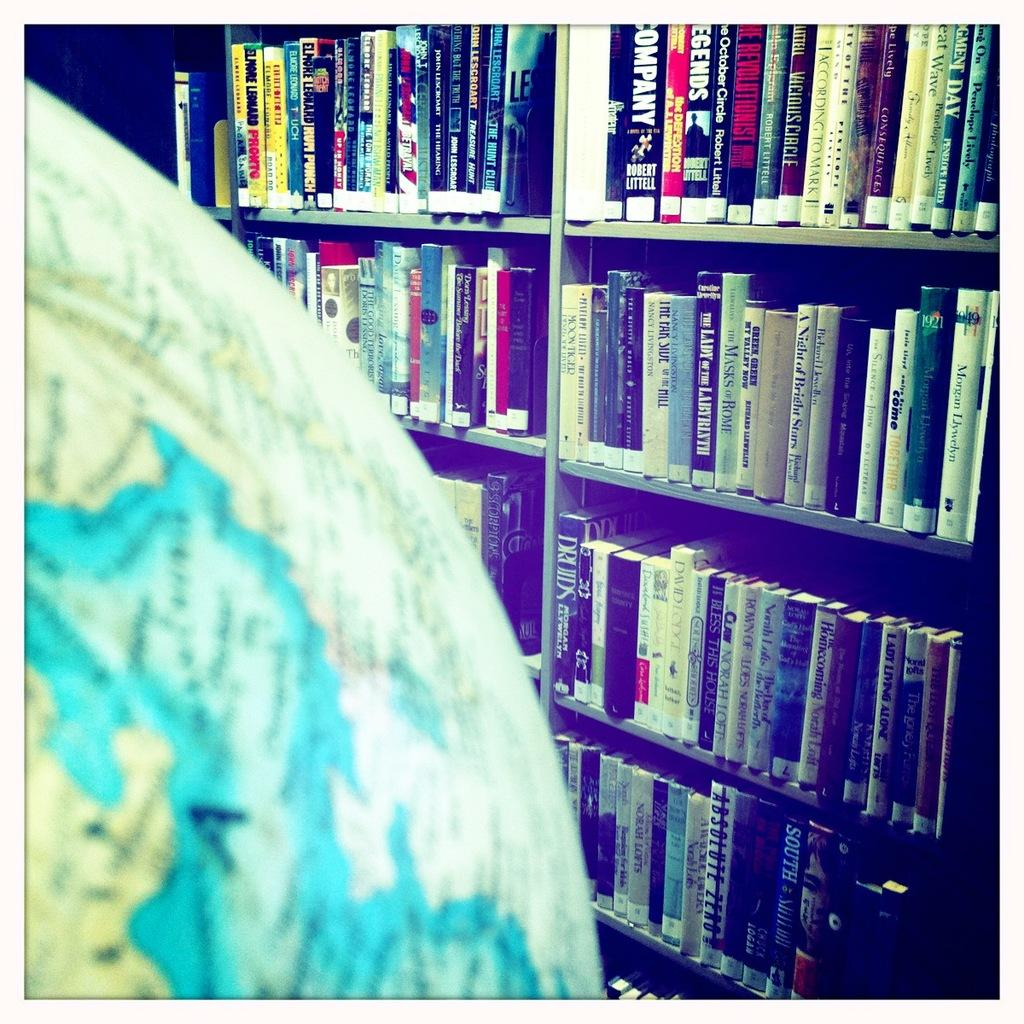<image>
Share a concise interpretation of the image provided. shelves of books with one of them saying 'company' on the spine 